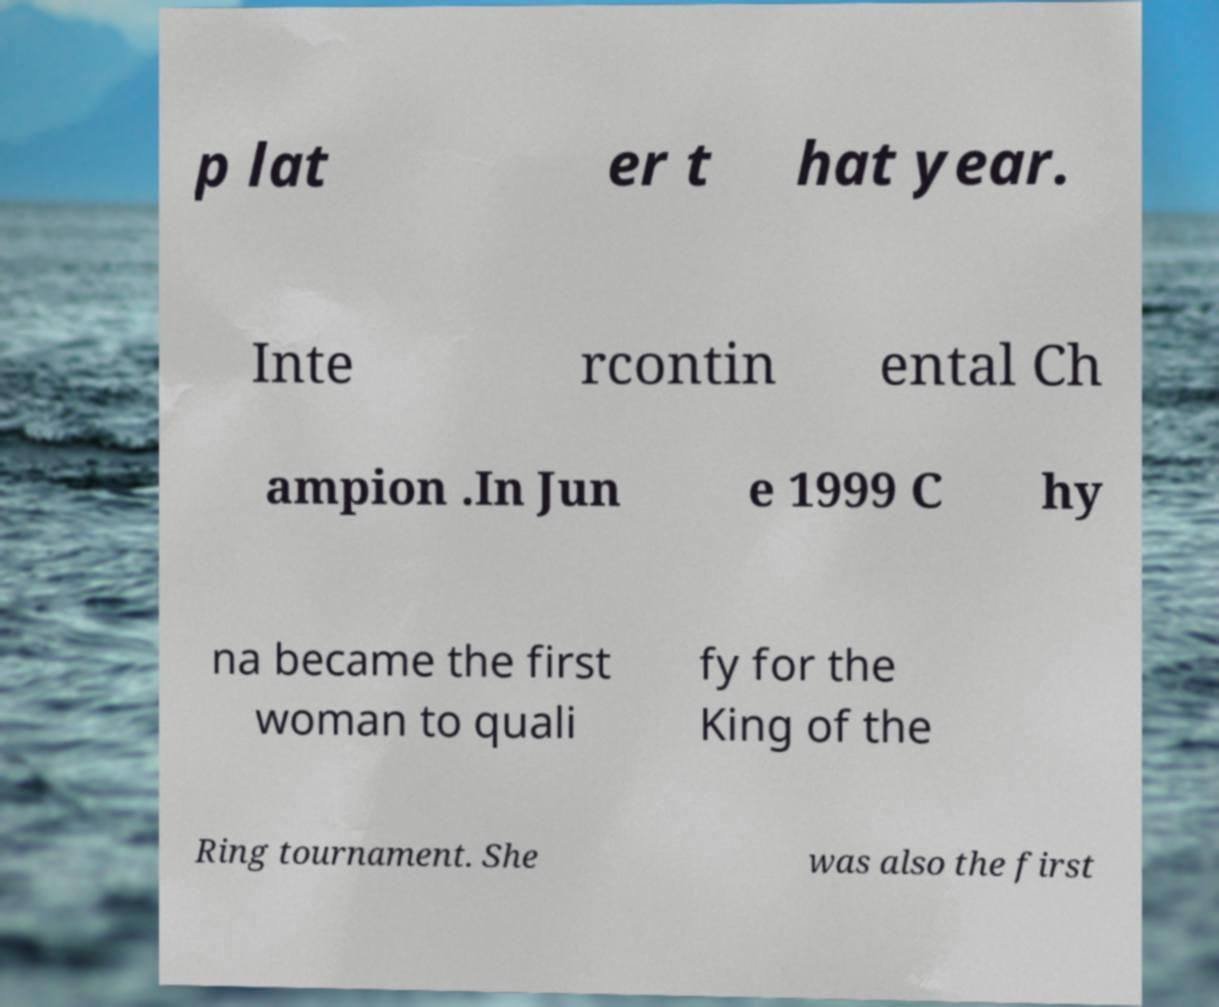What messages or text are displayed in this image? I need them in a readable, typed format. p lat er t hat year. Inte rcontin ental Ch ampion .In Jun e 1999 C hy na became the first woman to quali fy for the King of the Ring tournament. She was also the first 